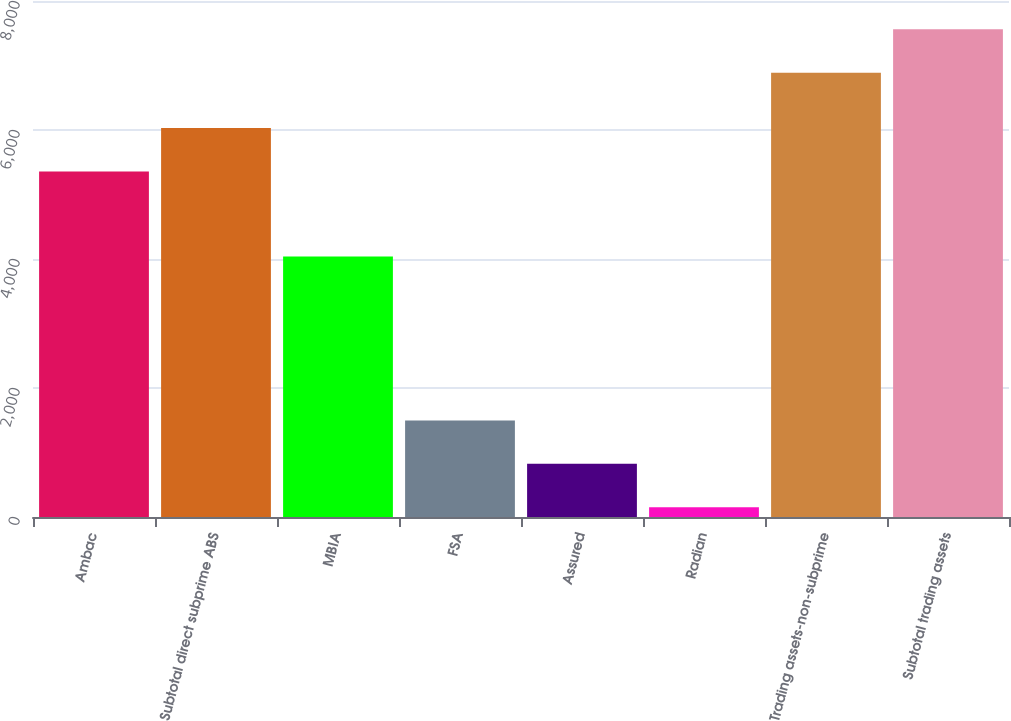Convert chart. <chart><loc_0><loc_0><loc_500><loc_500><bar_chart><fcel>Ambac<fcel>Subtotal direct subprime ABS<fcel>MBIA<fcel>FSA<fcel>Assured<fcel>Radian<fcel>Trading assets-non-subprime<fcel>Subtotal trading assets<nl><fcel>5357<fcel>6030.7<fcel>4040<fcel>1497.4<fcel>823.7<fcel>150<fcel>6887<fcel>7560.7<nl></chart> 